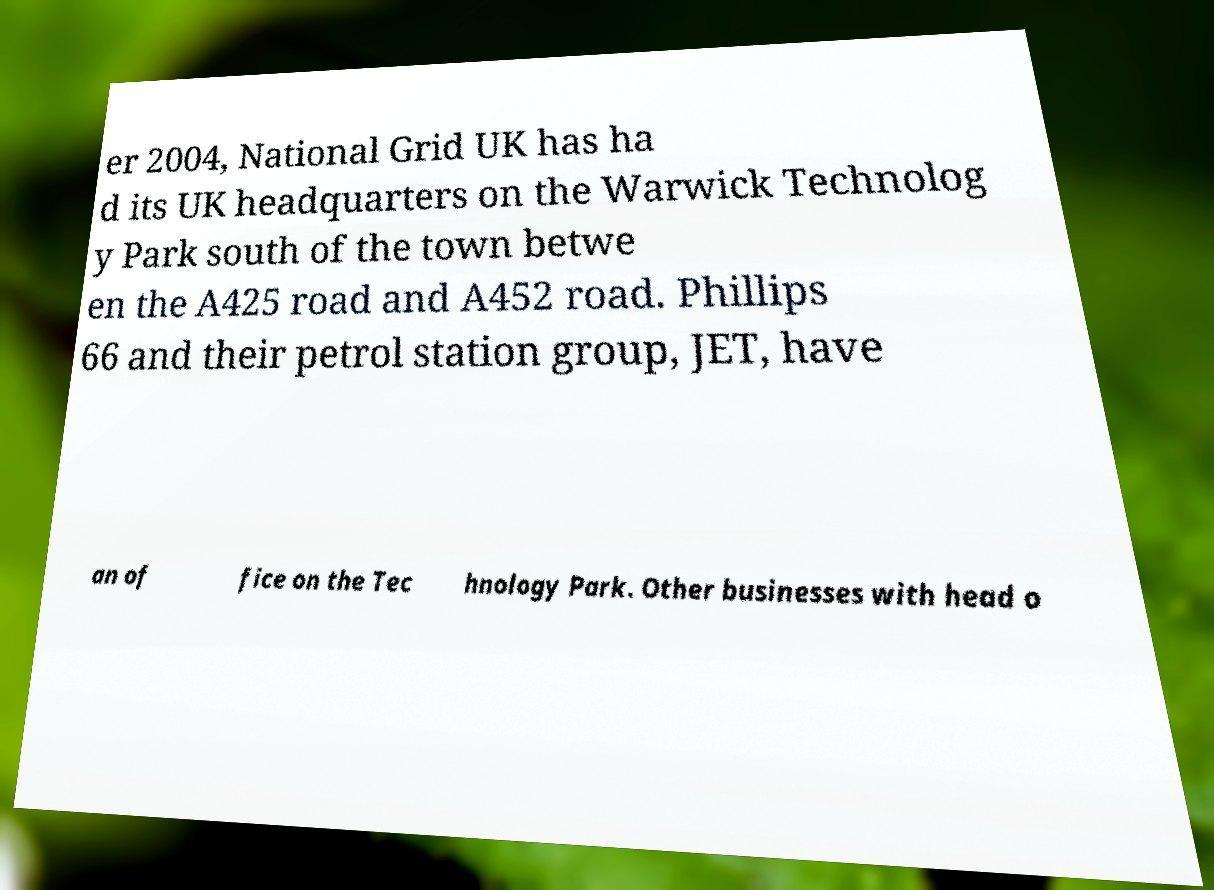What messages or text are displayed in this image? I need them in a readable, typed format. er 2004, National Grid UK has ha d its UK headquarters on the Warwick Technolog y Park south of the town betwe en the A425 road and A452 road. Phillips 66 and their petrol station group, JET, have an of fice on the Tec hnology Park. Other businesses with head o 